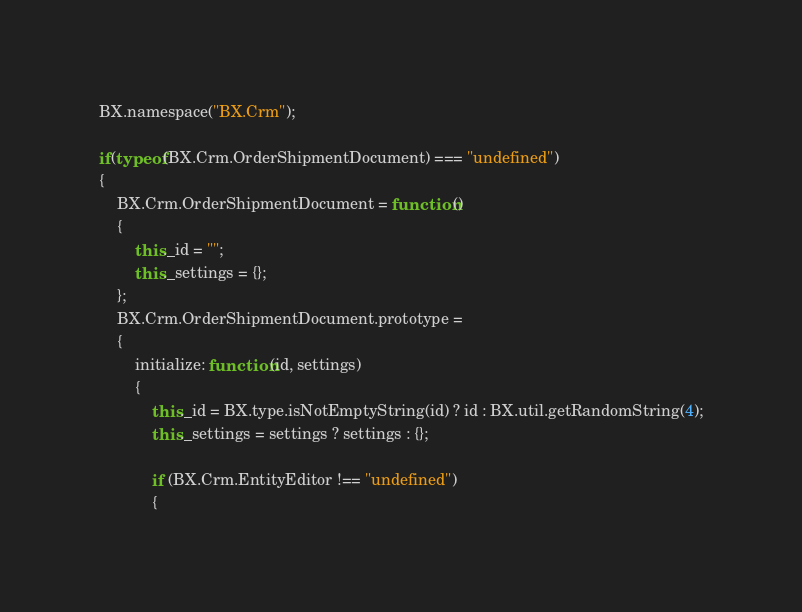<code> <loc_0><loc_0><loc_500><loc_500><_JavaScript_>BX.namespace("BX.Crm");

if(typeof(BX.Crm.OrderShipmentDocument) === "undefined")
{
	BX.Crm.OrderShipmentDocument = function()
	{
		this._id = "";
		this._settings = {};
	};
	BX.Crm.OrderShipmentDocument.prototype =
	{
		initialize: function(id, settings)
		{
			this._id = BX.type.isNotEmptyString(id) ? id : BX.util.getRandomString(4);
			this._settings = settings ? settings : {};

			if (BX.Crm.EntityEditor !== "undefined")
			{</code> 